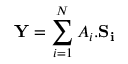Convert formula to latex. <formula><loc_0><loc_0><loc_500><loc_500>Y = \sum _ { i = 1 } ^ { N } A _ { i } . S _ { i }</formula> 